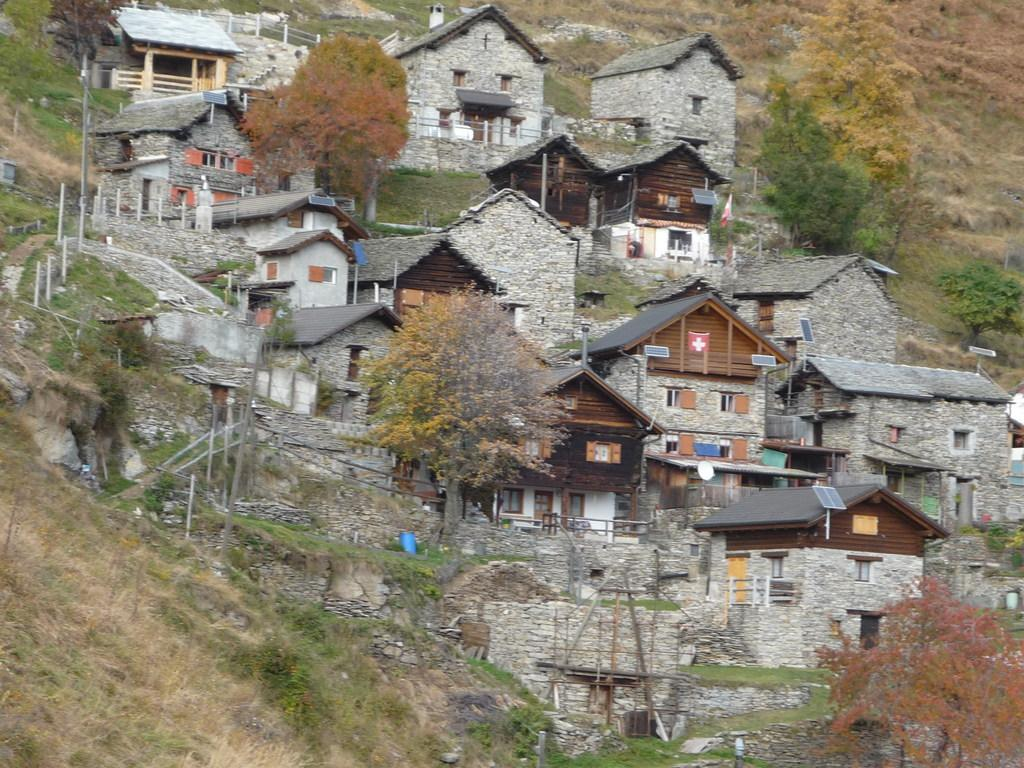What type of view is shown in the image? The image is an outside view. What structures can be seen in the image? There are many buildings in the image. What type of vegetation is present in the image? There are trees in the image. What is visible on the ground at the bottom of the image? Grass is visible on the ground at the bottom of the image. How many friends are sitting on the fork in the image? There is no fork present in the image. Does the existence of the buildings in the image prove the existence of aliens? The presence of buildings in the image does not prove the existence of aliens; it simply shows a view of buildings and trees. 